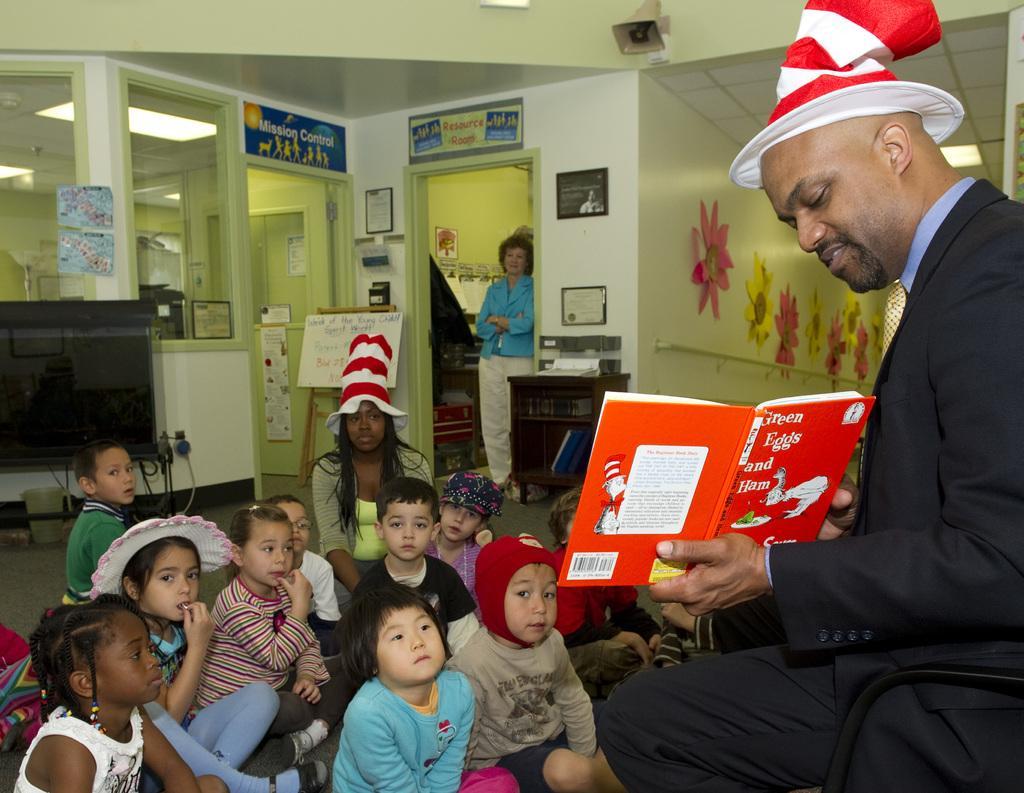Can you describe this image briefly? In this image we can see a man sitting on a chair wearing a hat and holding a book. We can also see a group of children and a woman sitting on the floor. On the backside we can see a television, some wires, boards with some text on it, a woman standing beside a door, some frames and pictures on a wall, window, a container on the floor, some papers placed on the cupboard and a roof with some ceiling lights. 